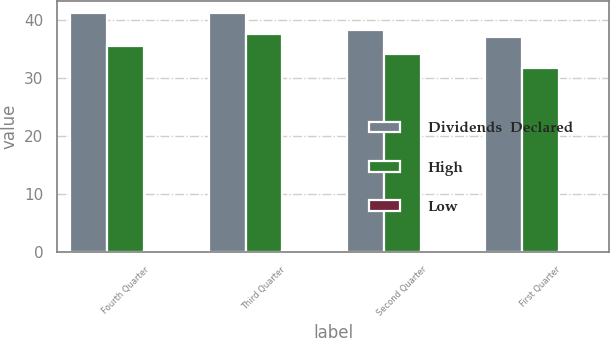Convert chart. <chart><loc_0><loc_0><loc_500><loc_500><stacked_bar_chart><ecel><fcel>Fourth Quarter<fcel>Third Quarter<fcel>Second Quarter<fcel>First Quarter<nl><fcel>Dividends  Declared<fcel>41.28<fcel>41.25<fcel>38.2<fcel>37<nl><fcel>High<fcel>35.56<fcel>37.54<fcel>34.09<fcel>31.77<nl><fcel>Low<fcel>0.25<fcel>0.25<fcel>0.25<fcel>0.23<nl></chart> 